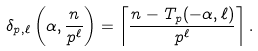Convert formula to latex. <formula><loc_0><loc_0><loc_500><loc_500>\delta _ { p , \ell } \left ( \alpha , \frac { n } { p ^ { \ell } } \right ) = \left \lceil \frac { n - T _ { p } ( - \alpha , \ell ) } { p ^ { \ell } } \right \rceil .</formula> 